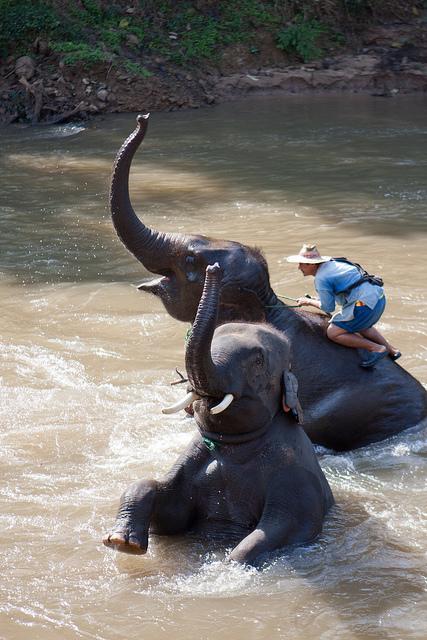How many elephants are there?
Give a very brief answer. 2. Are these elephants bathing?
Give a very brief answer. Yes. What age is the man riding the elephant?
Write a very short answer. 35. 